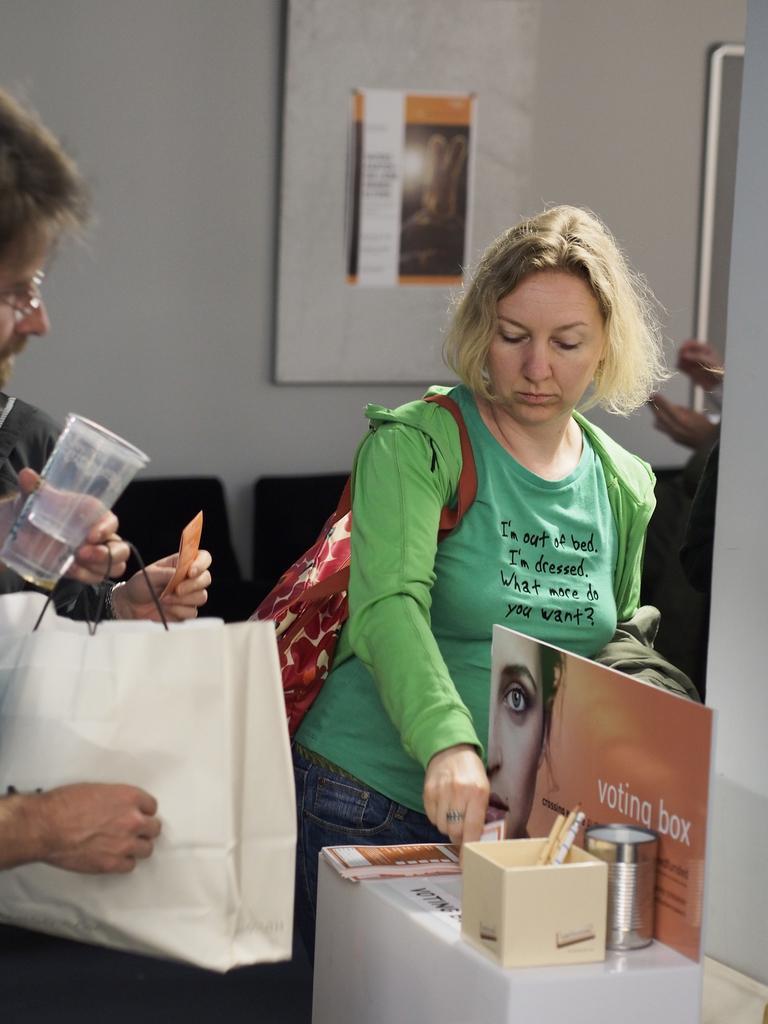Could you give a brief overview of what you see in this image? In this image there is a woman wearing a green top is standing, is also wearing a handbag. At left side there is a person holding a glass and bag. Behind to him there is another person holding a card. At the right bottom corner there is a table having box and poster. Behind this woman there is a boat having some poster. At the left side person hand is visible. 